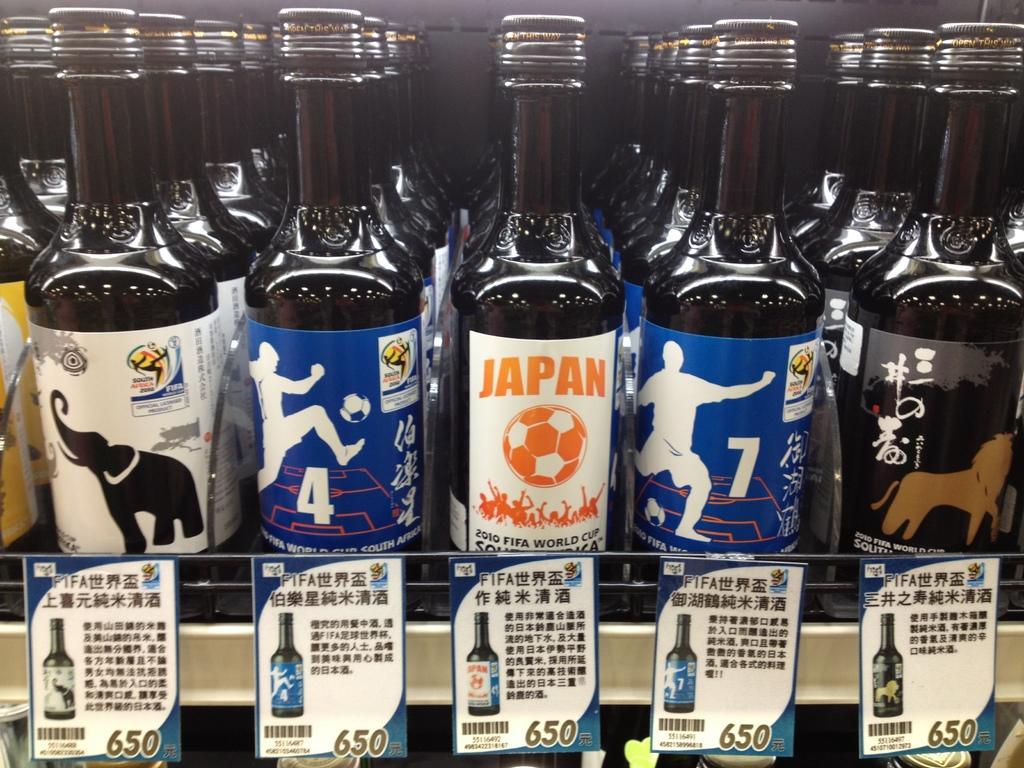Provide a one-sentence caption for the provided image. many bottles of black liquid are lined up for sale, including a bottle labeled JAPAN. 